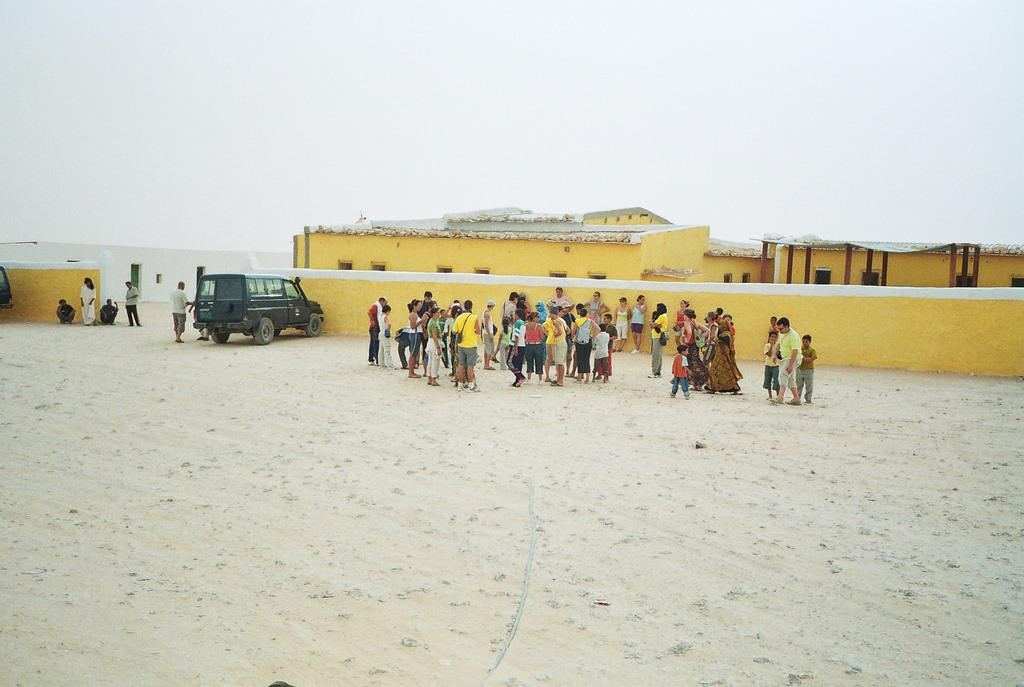What is in the foreground of the picture? There is sand in the foreground of the picture. What can be seen in the center of the picture? There are people, a wall, a car, and houses in the center of the picture. What is the condition of the sky in the picture? The sky is cloudy in the picture. What type of religion is being practiced in the center of the picture? There is no indication of any religious practice in the image; it features sand, people, a wall, a car, and houses. Can you tell me how many sofas are visible in the picture? There are no sofas present in the image. 